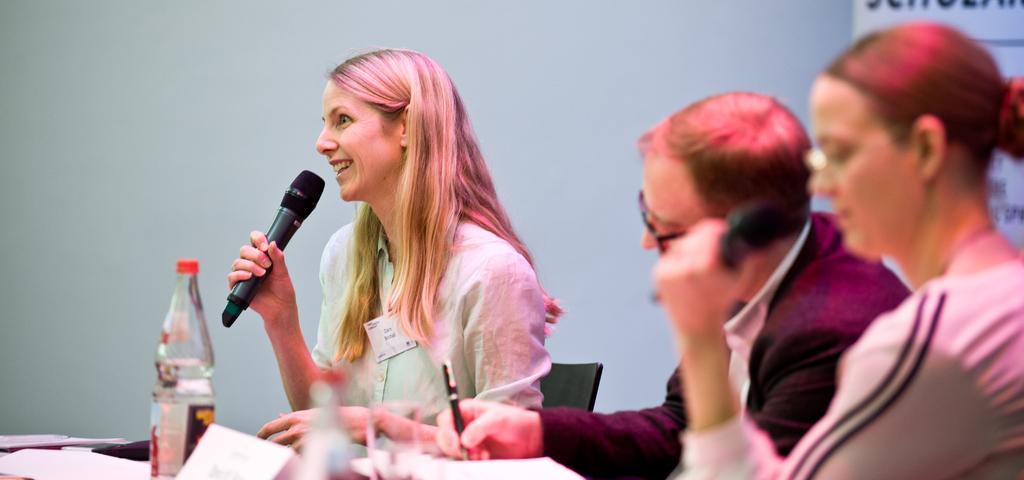In one or two sentences, can you explain what this image depicts? there are 3 people seated. the person at the left is holding a microphone and speaking. the person at the center is holding a pen. in front of them there are glass and bottles 